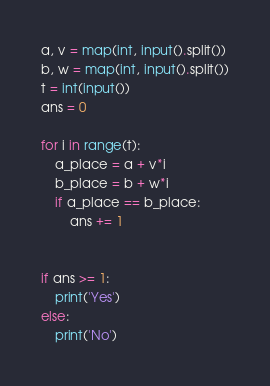<code> <loc_0><loc_0><loc_500><loc_500><_Python_>a, v = map(int, input().split())
b, w = map(int, input().split())
t = int(input())
ans = 0

for i in range(t):
    a_place = a + v*i
    b_place = b + w*i
    if a_place == b_place:
        ans += 1
    
    
if ans >= 1:
    print('Yes')
else:
    print('No')</code> 